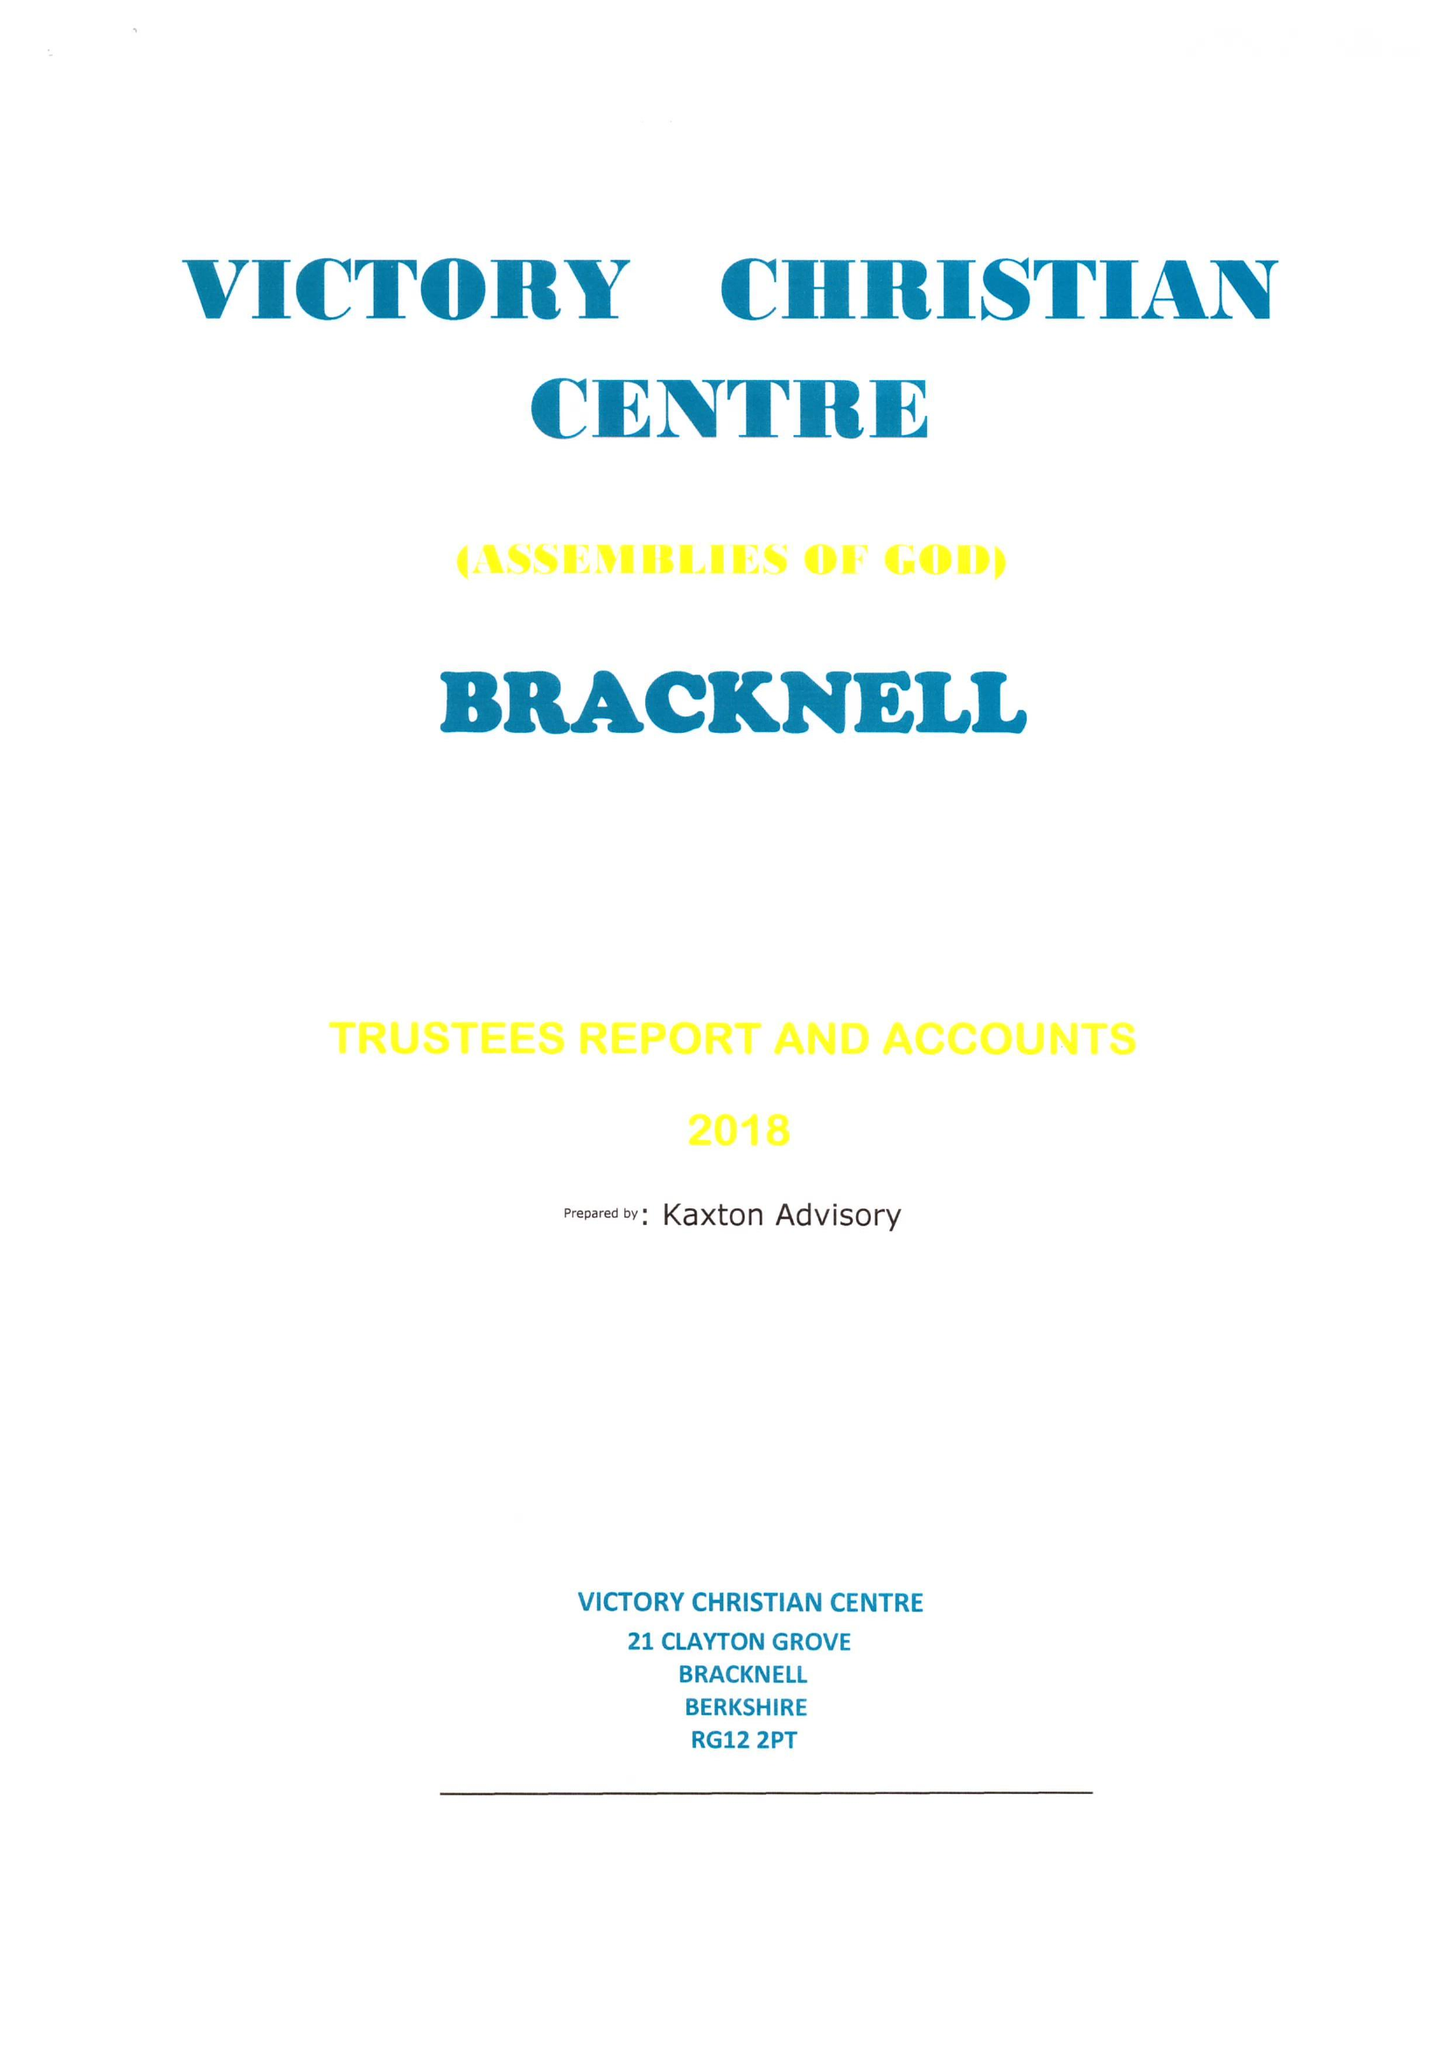What is the value for the address__street_line?
Answer the question using a single word or phrase. 21 CLAYTON GROVE 